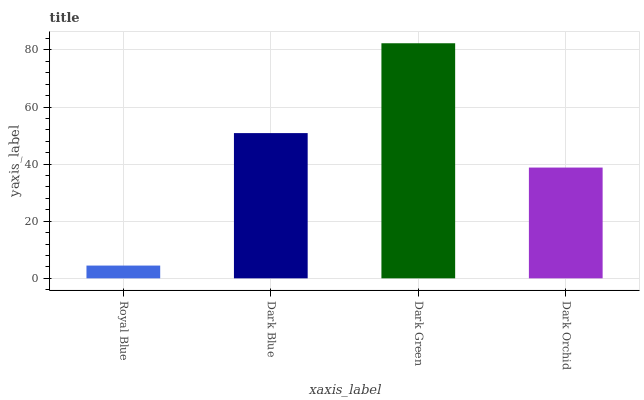Is Royal Blue the minimum?
Answer yes or no. Yes. Is Dark Green the maximum?
Answer yes or no. Yes. Is Dark Blue the minimum?
Answer yes or no. No. Is Dark Blue the maximum?
Answer yes or no. No. Is Dark Blue greater than Royal Blue?
Answer yes or no. Yes. Is Royal Blue less than Dark Blue?
Answer yes or no. Yes. Is Royal Blue greater than Dark Blue?
Answer yes or no. No. Is Dark Blue less than Royal Blue?
Answer yes or no. No. Is Dark Blue the high median?
Answer yes or no. Yes. Is Dark Orchid the low median?
Answer yes or no. Yes. Is Dark Green the high median?
Answer yes or no. No. Is Royal Blue the low median?
Answer yes or no. No. 